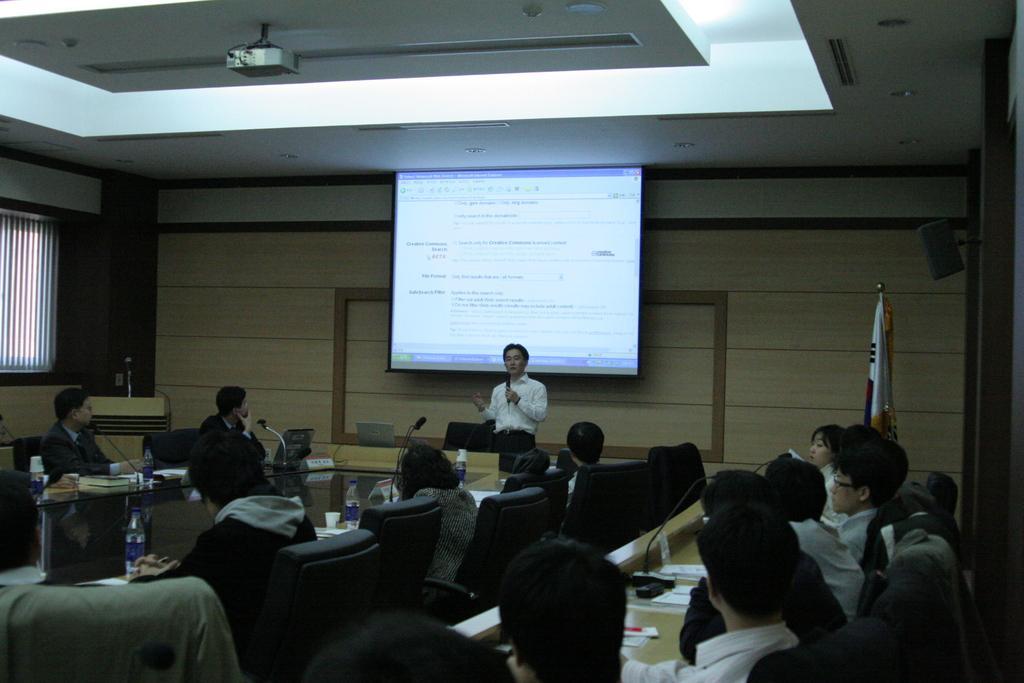How would you summarize this image in a sentence or two? This picture is taken inside the room. In this image, we can see a group of people sitting on the chair in front of the table. On the table, we can see some papers, microphone, water bottle. In the middle of the image, we can see a man standing and holding a microphone in his hand. On the left side, we can see a podium. On the podium, we can see a microphone. On the left side, we can see window, curtain. On the right side, we can see a flag. In the background, we can see a screen, on the screen, we can see some text written on it. At the top, we can see a roof and a projector. 